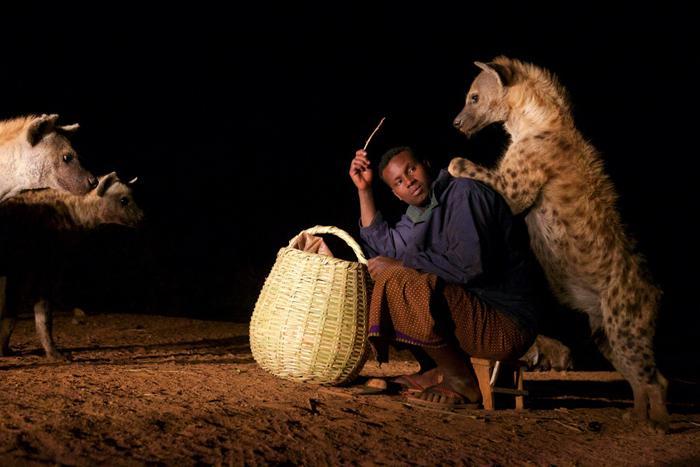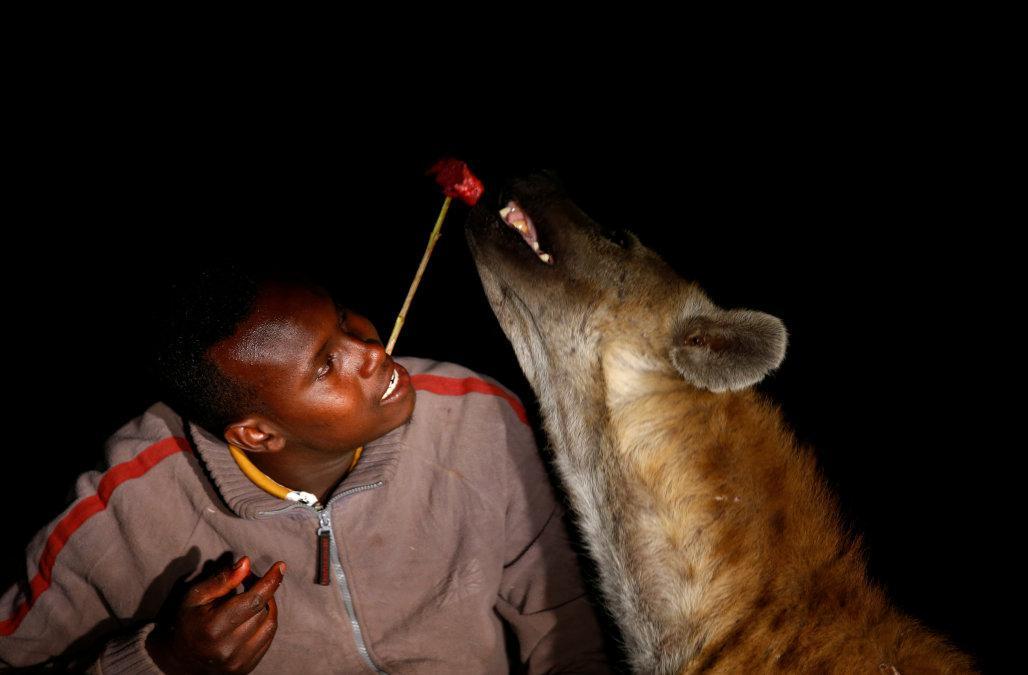The first image is the image on the left, the second image is the image on the right. Analyze the images presented: Is the assertion "The left image contains a human interacting with a hyena." valid? Answer yes or no. Yes. 